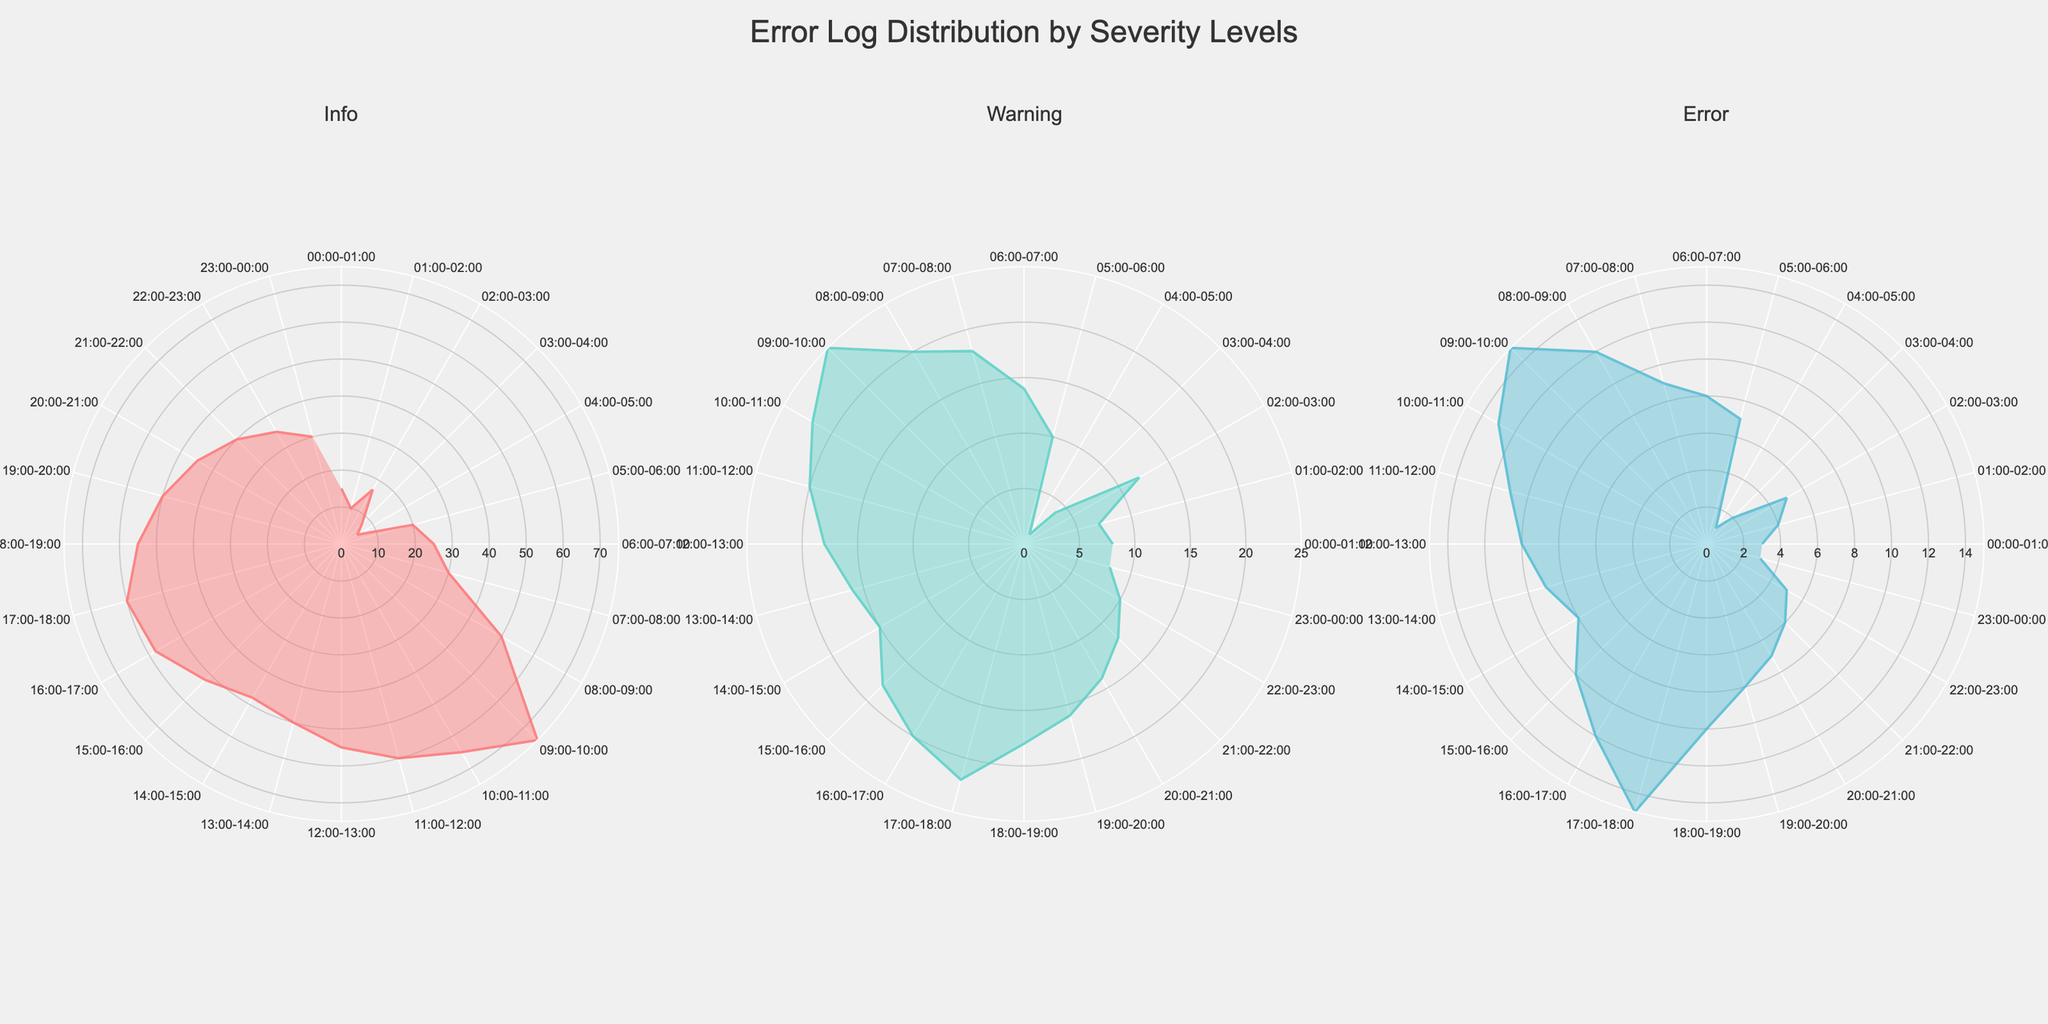What is the title of the plot? The title is typically displayed prominently at the top of the plot. In this case, the title reads "Error Log Distribution by Severity Levels".
Answer: Error Log Distribution by Severity Levels Which severity level shows the highest number of logs in the interval from 09:00 to 10:00? To determine which severity level has the highest number of logs for a specific time interval, look at the radial values in the polar chart for that interval. For the interval from 09:00 to 10:00, Info shows 75 logs, which is higher than Warning (25) and Error (15).
Answer: Info Which time interval has the highest count of Info logs? Look for the highest radial data point in the "Info" subplot. The 09:00-10:00 interval has the highest count of Info logs at 75.
Answer: 09:00-10:00 How many more Info logs are there compared to Warning logs in the interval from 08:00 to 09:00? To find the difference, subtract the number of Warning logs from the number of Info logs for the specified interval. Info logs are 50, and Warning logs are 20. Therefore, 50 - 20 = 30.
Answer: 30 What pattern can be observed in the Error logs across the day? To determine the pattern, look at the entire "Error" subplot and observe the variations throughout the 24-hour periods. The pattern starts with lower counts in early morning hours, peaks around 09:00 with 15 logs, and gradually decreases towards the end of the day.
Answer: Peaks around 09:00, then gradually decreases How does the number of Warning logs compare to Info logs during the interval from 06:00 to 07:00? Observe the radial data points in the "Warning" and "Info" subplots for the specified interval. Info has 25 logs, and Warning has 14 logs. Thus, Info logs are higher.
Answer: Info logs are higher What is the trend in the Info logs from 00:00 to 04:00? By tracing the radial data points in the "Info" subplot from 00:00 to 04:00, we see the counts go from 15 to 5, indicating a decreasing trend.
Answer: Decreasing Are there any intervals where the count of Error logs is consistent? Check the "Error" subplot for intervals where the radial data points remain the same. From 00:00-01:00 and 23:00-00:00, we see 3 Error logs consistently.
Answer: 00:00-01:00 and 23:00-00:00 Which interval shows the largest difference between Info logs and Error logs? For each interval, subtract the count of Error logs from Info logs. The interval with the largest difference is 09:00-10:00 with a difference of 75 (Info) - 15 (Error) = 60.
Answer: 09:00-10:00 